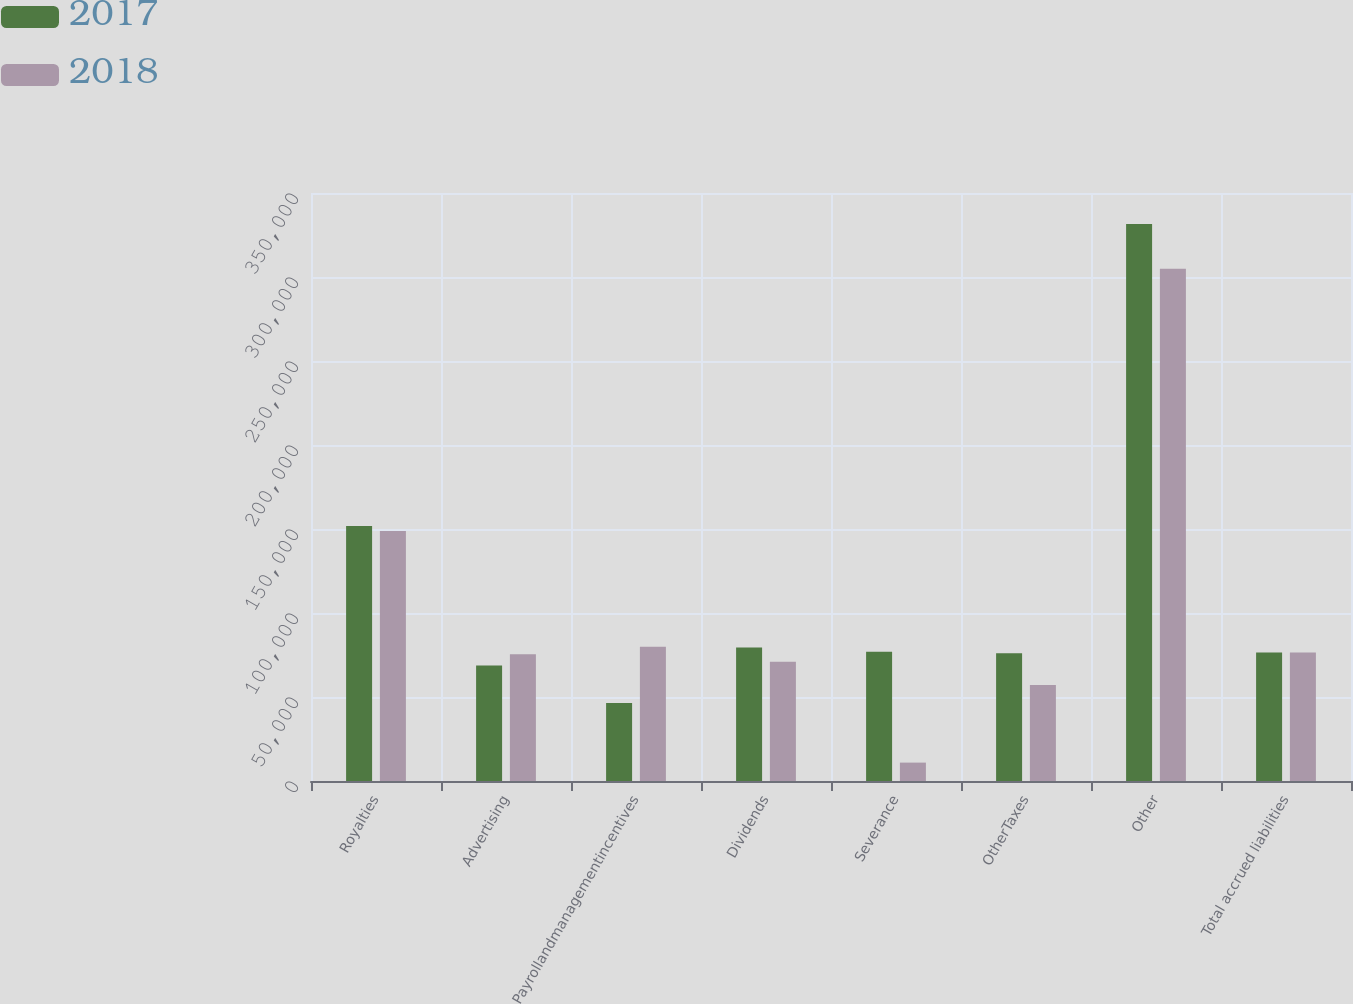Convert chart. <chart><loc_0><loc_0><loc_500><loc_500><stacked_bar_chart><ecel><fcel>Royalties<fcel>Advertising<fcel>Payrollandmanagementincentives<fcel>Dividends<fcel>Severance<fcel>OtherTaxes<fcel>Other<fcel>Total accrued liabilities<nl><fcel>2017<fcel>151852<fcel>68811<fcel>46472<fcel>79461<fcel>76920<fcel>75973<fcel>331574<fcel>76446.5<nl><fcel>2018<fcel>148858<fcel>75483<fcel>79976<fcel>70936<fcel>10952<fcel>57155<fcel>304904<fcel>76446.5<nl></chart> 